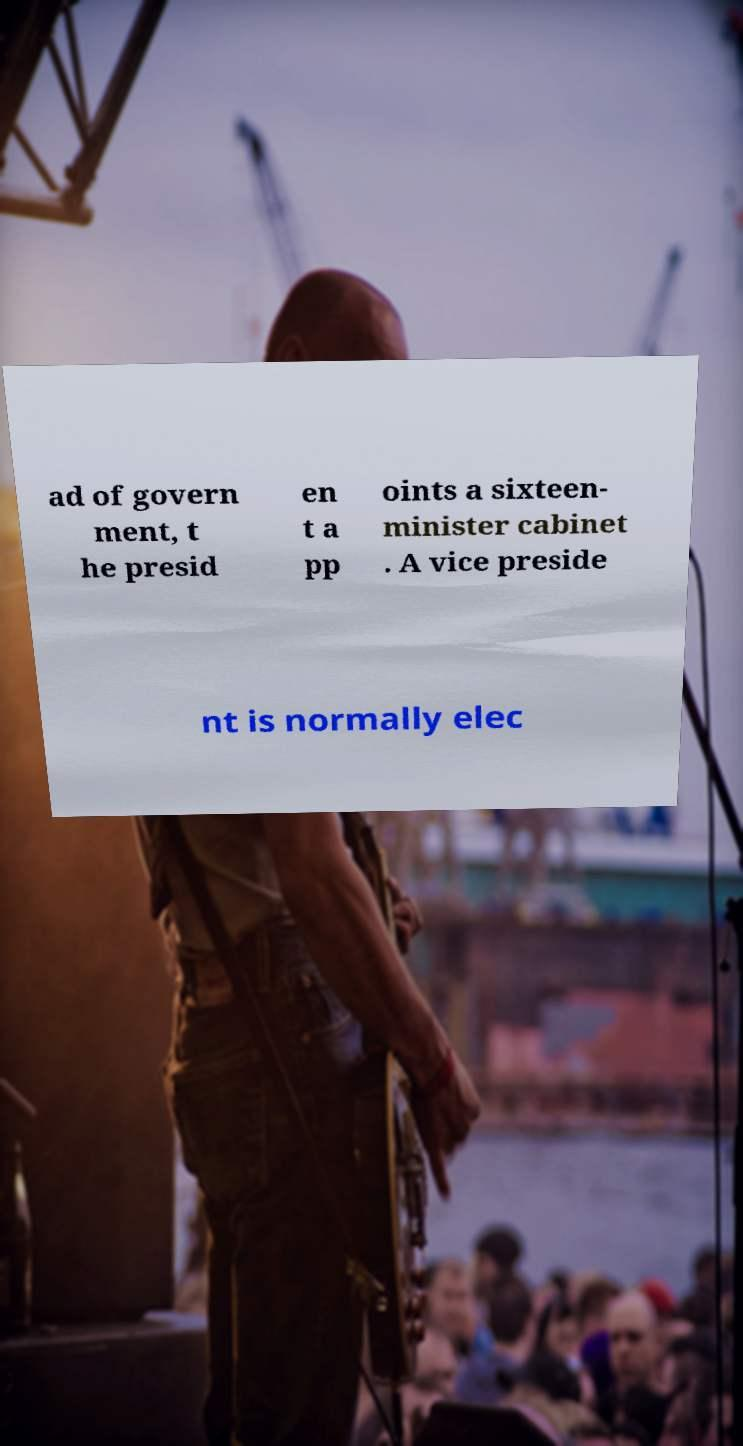I need the written content from this picture converted into text. Can you do that? ad of govern ment, t he presid en t a pp oints a sixteen- minister cabinet . A vice preside nt is normally elec 